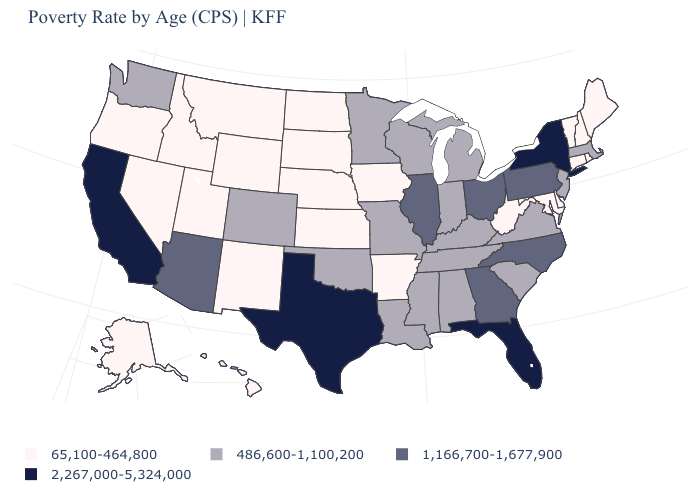Does Delaware have the lowest value in the USA?
Answer briefly. Yes. Name the states that have a value in the range 1,166,700-1,677,900?
Give a very brief answer. Arizona, Georgia, Illinois, North Carolina, Ohio, Pennsylvania. Is the legend a continuous bar?
Quick response, please. No. What is the value of Oregon?
Concise answer only. 65,100-464,800. Name the states that have a value in the range 1,166,700-1,677,900?
Concise answer only. Arizona, Georgia, Illinois, North Carolina, Ohio, Pennsylvania. Which states have the lowest value in the USA?
Short answer required. Alaska, Arkansas, Connecticut, Delaware, Hawaii, Idaho, Iowa, Kansas, Maine, Maryland, Montana, Nebraska, Nevada, New Hampshire, New Mexico, North Dakota, Oregon, Rhode Island, South Dakota, Utah, Vermont, West Virginia, Wyoming. Name the states that have a value in the range 486,600-1,100,200?
Give a very brief answer. Alabama, Colorado, Indiana, Kentucky, Louisiana, Massachusetts, Michigan, Minnesota, Mississippi, Missouri, New Jersey, Oklahoma, South Carolina, Tennessee, Virginia, Washington, Wisconsin. Does the map have missing data?
Write a very short answer. No. Name the states that have a value in the range 2,267,000-5,324,000?
Be succinct. California, Florida, New York, Texas. Name the states that have a value in the range 65,100-464,800?
Short answer required. Alaska, Arkansas, Connecticut, Delaware, Hawaii, Idaho, Iowa, Kansas, Maine, Maryland, Montana, Nebraska, Nevada, New Hampshire, New Mexico, North Dakota, Oregon, Rhode Island, South Dakota, Utah, Vermont, West Virginia, Wyoming. Which states have the lowest value in the USA?
Keep it brief. Alaska, Arkansas, Connecticut, Delaware, Hawaii, Idaho, Iowa, Kansas, Maine, Maryland, Montana, Nebraska, Nevada, New Hampshire, New Mexico, North Dakota, Oregon, Rhode Island, South Dakota, Utah, Vermont, West Virginia, Wyoming. Among the states that border Utah , which have the lowest value?
Be succinct. Idaho, Nevada, New Mexico, Wyoming. Name the states that have a value in the range 65,100-464,800?
Write a very short answer. Alaska, Arkansas, Connecticut, Delaware, Hawaii, Idaho, Iowa, Kansas, Maine, Maryland, Montana, Nebraska, Nevada, New Hampshire, New Mexico, North Dakota, Oregon, Rhode Island, South Dakota, Utah, Vermont, West Virginia, Wyoming. Which states have the lowest value in the USA?
Keep it brief. Alaska, Arkansas, Connecticut, Delaware, Hawaii, Idaho, Iowa, Kansas, Maine, Maryland, Montana, Nebraska, Nevada, New Hampshire, New Mexico, North Dakota, Oregon, Rhode Island, South Dakota, Utah, Vermont, West Virginia, Wyoming. Is the legend a continuous bar?
Concise answer only. No. 